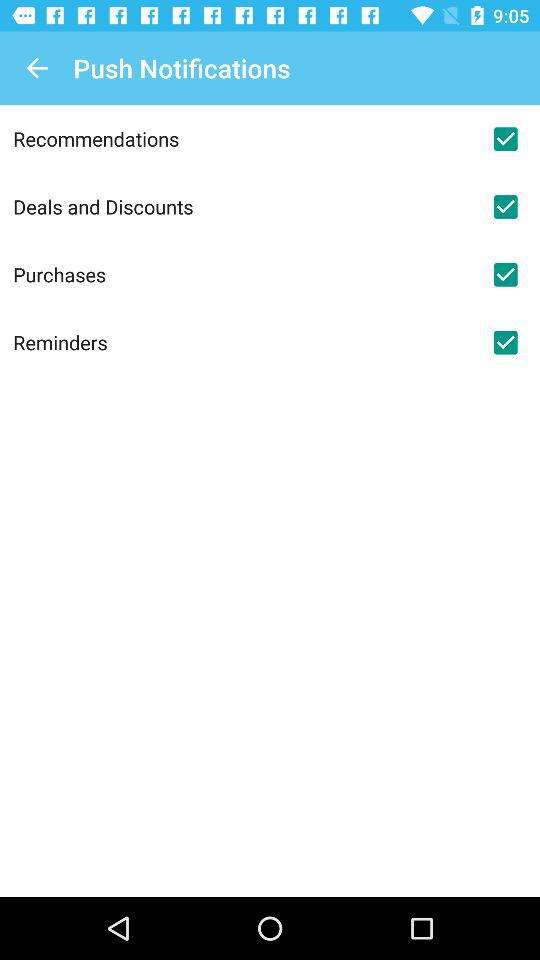What is the status of reminders? The status is on. 